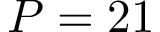Convert formula to latex. <formula><loc_0><loc_0><loc_500><loc_500>P = 2 1</formula> 